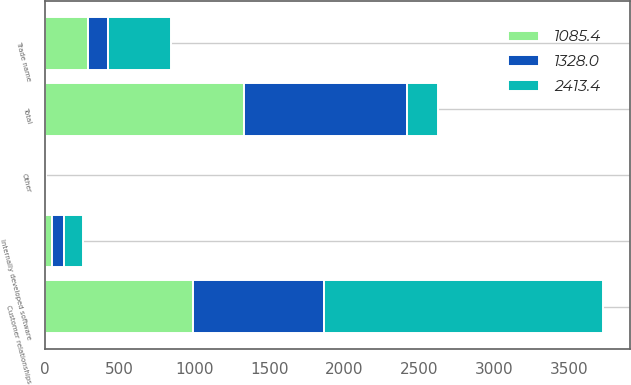Convert chart. <chart><loc_0><loc_0><loc_500><loc_500><stacked_bar_chart><ecel><fcel>Customer relationships<fcel>Trade name<fcel>Internally developed software<fcel>Other<fcel>Total<nl><fcel>2413.4<fcel>1860.8<fcel>421<fcel>128.5<fcel>3.1<fcel>210.5<nl><fcel>1328<fcel>872.8<fcel>130.9<fcel>79.8<fcel>1.9<fcel>1085.4<nl><fcel>1085.4<fcel>988<fcel>290.1<fcel>48.7<fcel>1.2<fcel>1328<nl></chart> 